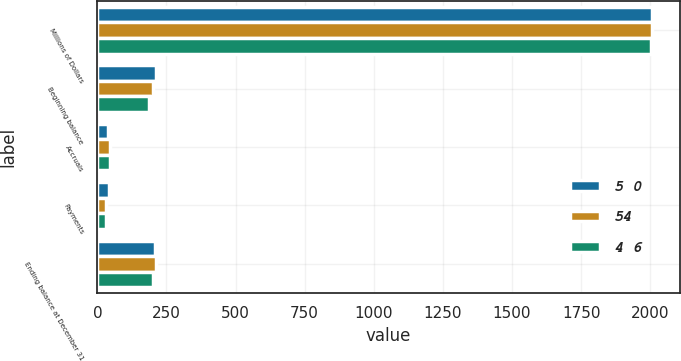Convert chart. <chart><loc_0><loc_0><loc_500><loc_500><stacked_bar_chart><ecel><fcel>Millions of Dollars<fcel>Beginning balance<fcel>Accruals<fcel>Payments<fcel>Ending balance at December 31<nl><fcel>5 0<fcel>2006<fcel>213<fcel>39<fcel>42<fcel>210<nl><fcel>54<fcel>2005<fcel>201<fcel>45<fcel>33<fcel>213<nl><fcel>4 6<fcel>2004<fcel>187<fcel>46<fcel>32<fcel>201<nl></chart> 